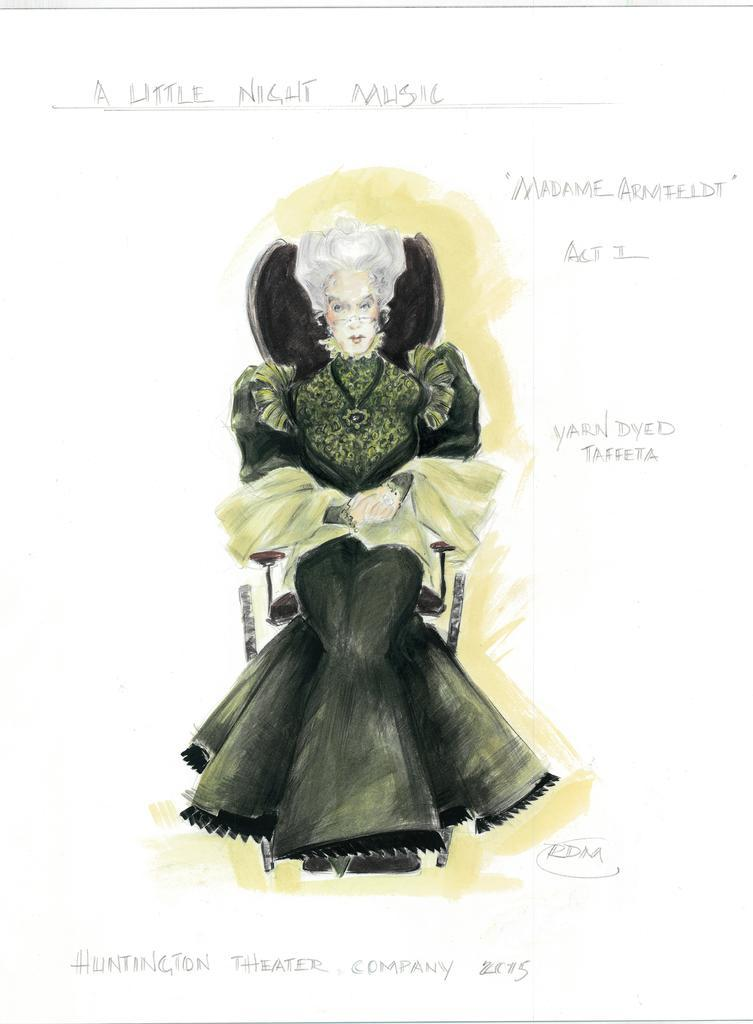What is the primary subject in the image? There is a woman sitting in the center of the image. What type of artwork might this image be? The image might be a painting. Can you describe any text present in the image? There is text at the top and bottom of the image. How many girls are flying in the image? There are no girls flying in the image; it features a woman sitting in the center. What is the mass of the object depicted in the image? It is not possible to determine the mass of the object depicted in the image without additional information. 